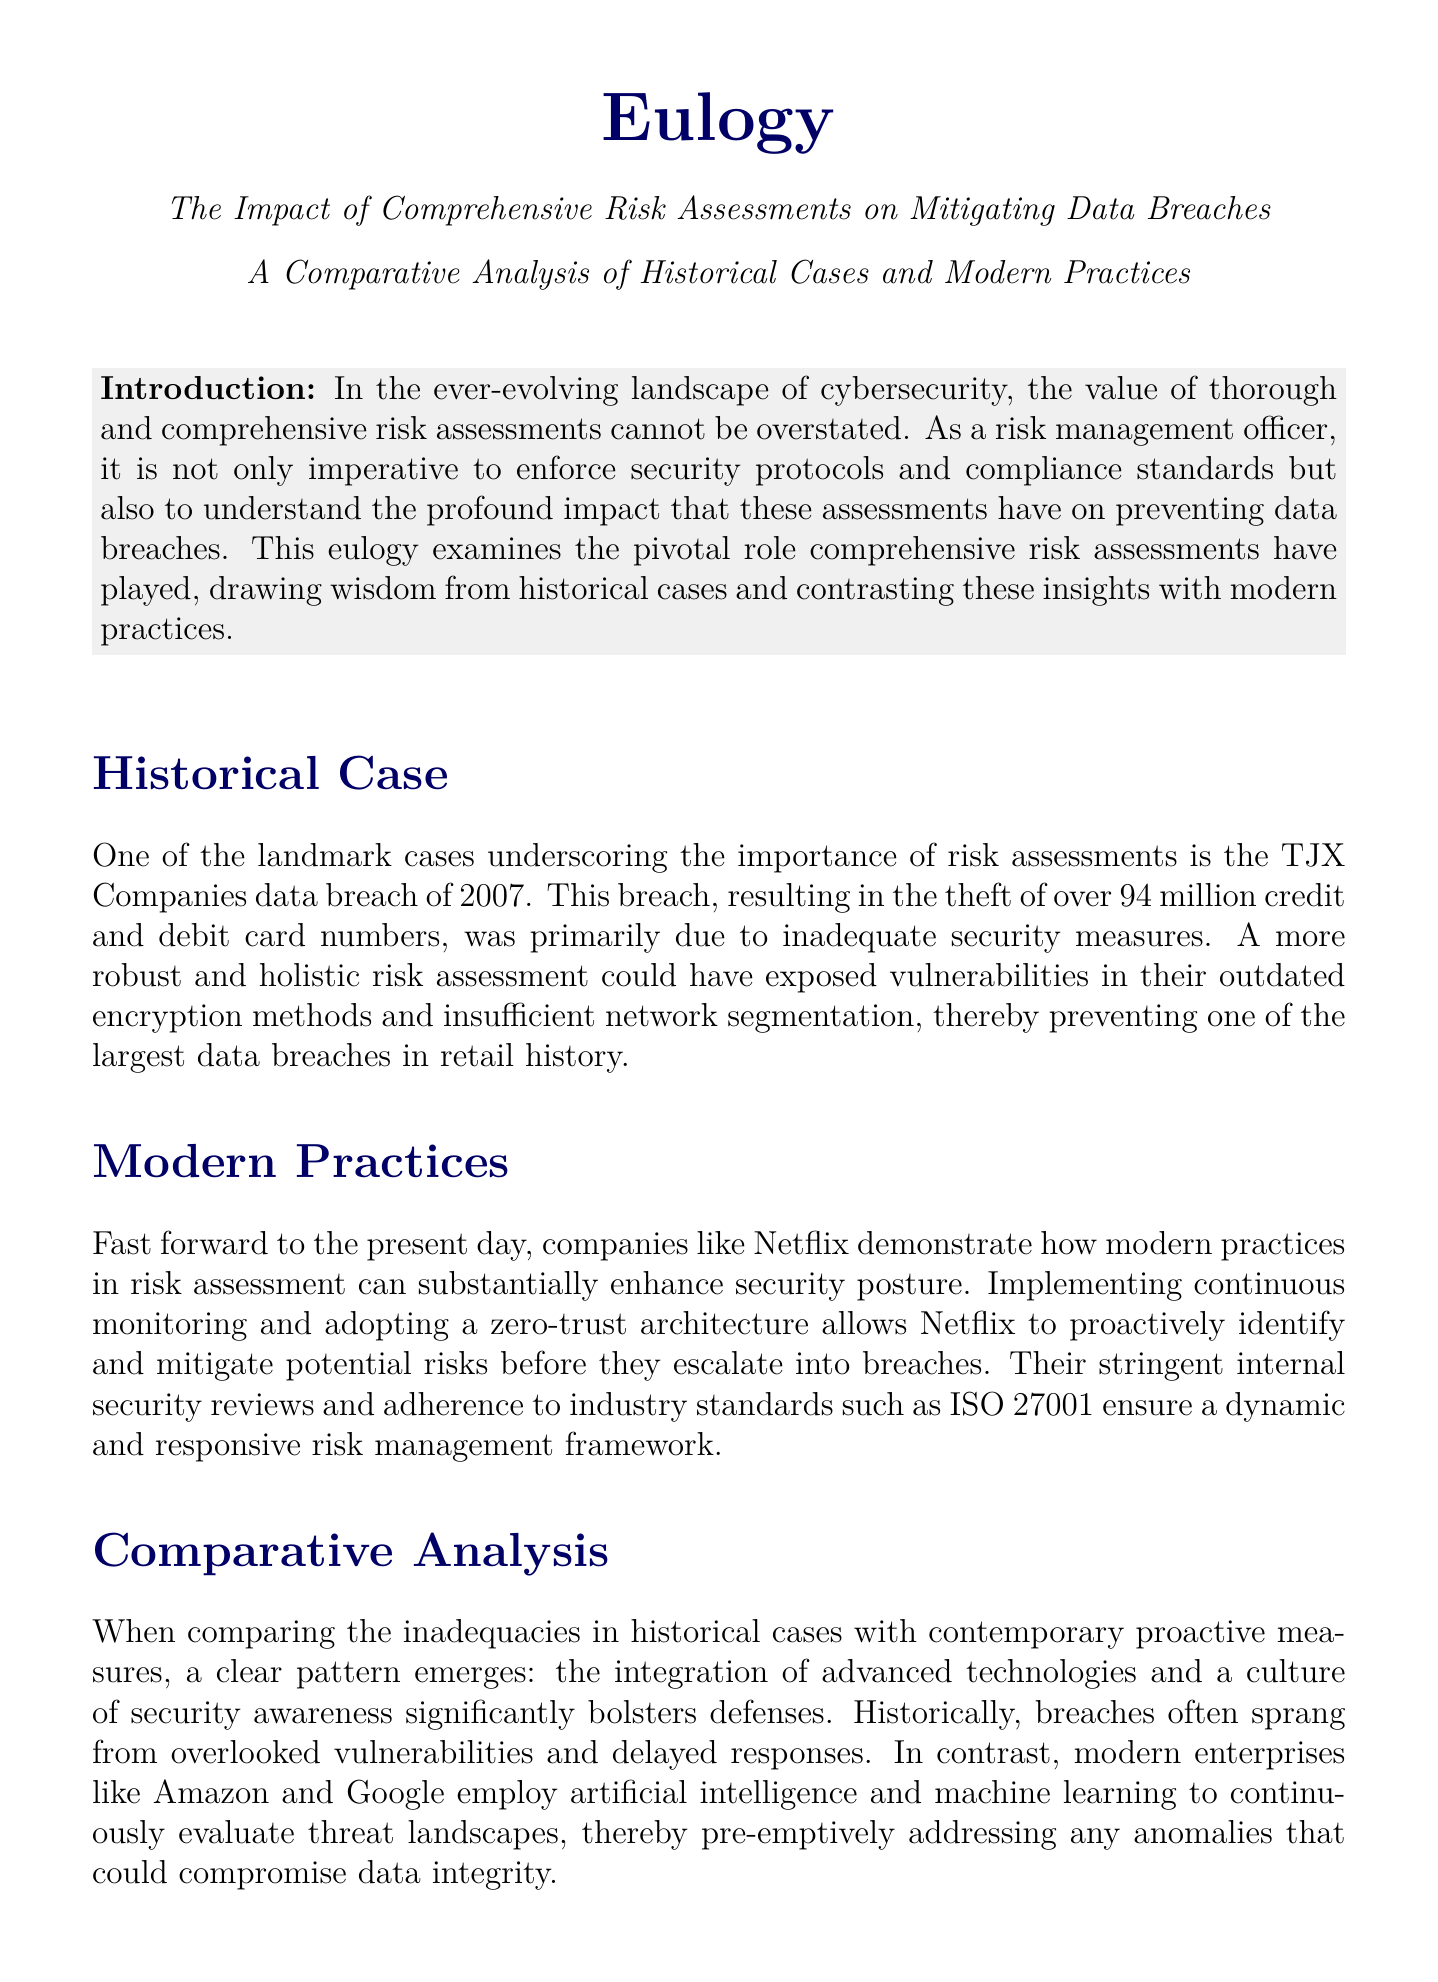what is the title of the eulogy? The title of the eulogy is mentioned at the top of the document, emphasizing its focus on risk assessments and data breaches.
Answer: The Impact of Comprehensive Risk Assessments on Mitigating Data Breaches what year did the TJX Companies data breach occur? The year of the TJX Companies data breach is specified in the historical case section.
Answer: 2007 how many credit and debit card numbers were stolen in the TJX Companies breach? The number of stolen card numbers is detailed in the historical case section.
Answer: 94 million what modern company's practices are highlighted as examples in the document? The section on modern practices specifically mentions a contemporary company that employs advanced risk assessment methods.
Answer: Netflix what security architecture does Netflix adopt? The eulogy discusses the framework Netflix employs to enhance its security approach.
Answer: zero-trust architecture which organization is mentioned as adhering to industry standards like ISO 27001? The text indicates that this organization implements specific standards to maintain its security posture.
Answer: Netflix what is the primary focus of comprehensive risk assessments? The conclusion of the document describes the essential purpose of conducting these assessments.
Answer: sustainable data protection strategies which two organizations are mentioned as employing artificial intelligence for risk management? The comparative analysis section refers to two companies known for proactive measures in risk assessment.
Answer: Amazon and Google what is a key lesson learned from historical data breaches? The document reflects on the insights gained from past incidents regarding risk management.
Answer: overlooked vulnerabilities 